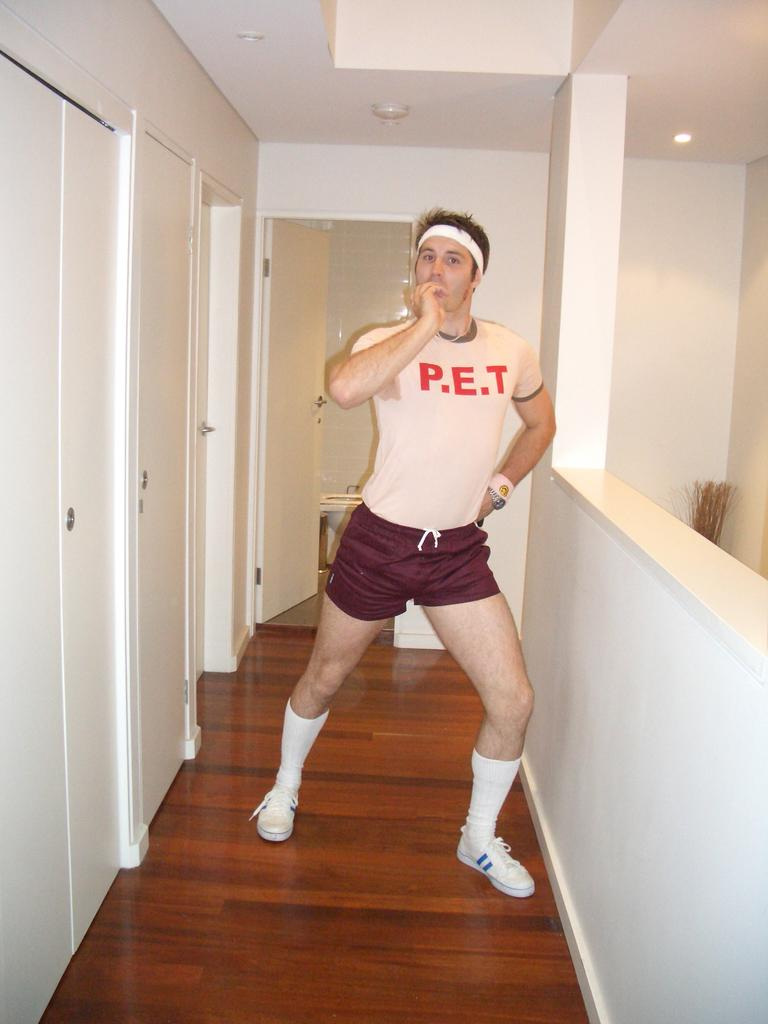Provide a one-sentence caption for the provided image. a man that has P.E.T on his shirt. 